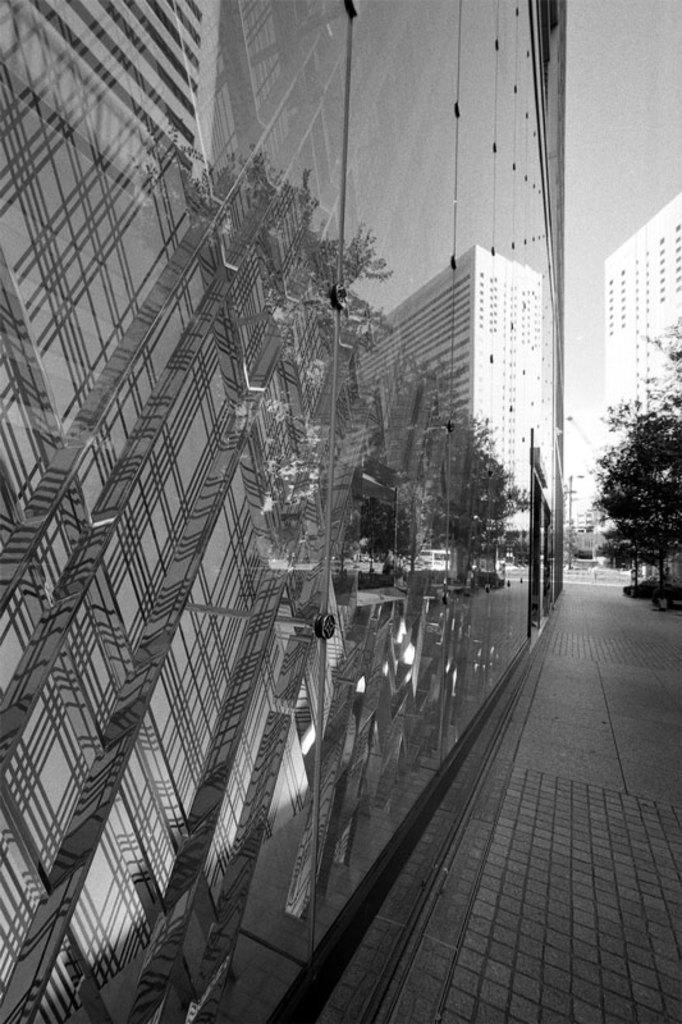What structures are located in the middle of the picture? There are buildings in the middle of the picture. What type of vegetation is on the right side of the picture? There are trees on the right side of the picture. What is visible in the background of the picture? The sky is visible in the background of the picture. Where is the oven located in the picture? There is no oven present in the picture. What type of desk can be seen on the left side of the picture? There is no desk present in the picture. 